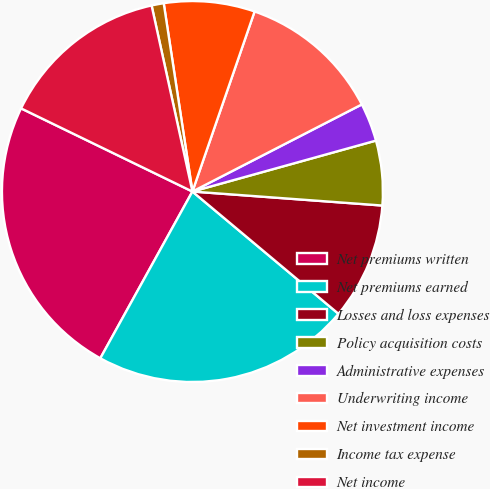<chart> <loc_0><loc_0><loc_500><loc_500><pie_chart><fcel>Net premiums written<fcel>Net premiums earned<fcel>Losses and loss expenses<fcel>Policy acquisition costs<fcel>Administrative expenses<fcel>Underwriting income<fcel>Net investment income<fcel>Income tax expense<fcel>Net income<nl><fcel>24.16%<fcel>21.94%<fcel>9.92%<fcel>5.48%<fcel>3.25%<fcel>12.15%<fcel>7.7%<fcel>1.03%<fcel>14.37%<nl></chart> 